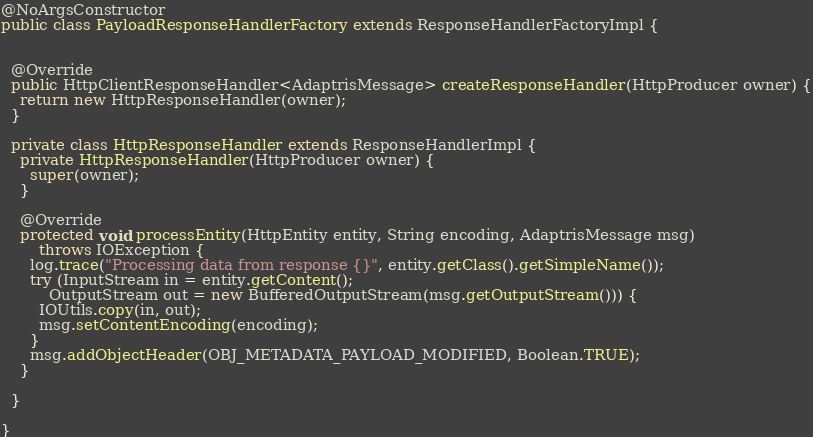<code> <loc_0><loc_0><loc_500><loc_500><_Java_>@NoArgsConstructor
public class PayloadResponseHandlerFactory extends ResponseHandlerFactoryImpl {


  @Override
  public HttpClientResponseHandler<AdaptrisMessage> createResponseHandler(HttpProducer owner) {
    return new HttpResponseHandler(owner);
  }

  private class HttpResponseHandler extends ResponseHandlerImpl {
    private HttpResponseHandler(HttpProducer owner) {
      super(owner);
    }

    @Override
    protected void processEntity(HttpEntity entity, String encoding, AdaptrisMessage msg)
        throws IOException {
      log.trace("Processing data from response {}", entity.getClass().getSimpleName());
      try (InputStream in = entity.getContent();
          OutputStream out = new BufferedOutputStream(msg.getOutputStream())) {
        IOUtils.copy(in, out);
        msg.setContentEncoding(encoding);
      }
      msg.addObjectHeader(OBJ_METADATA_PAYLOAD_MODIFIED, Boolean.TRUE);
    }

  }

}
</code> 